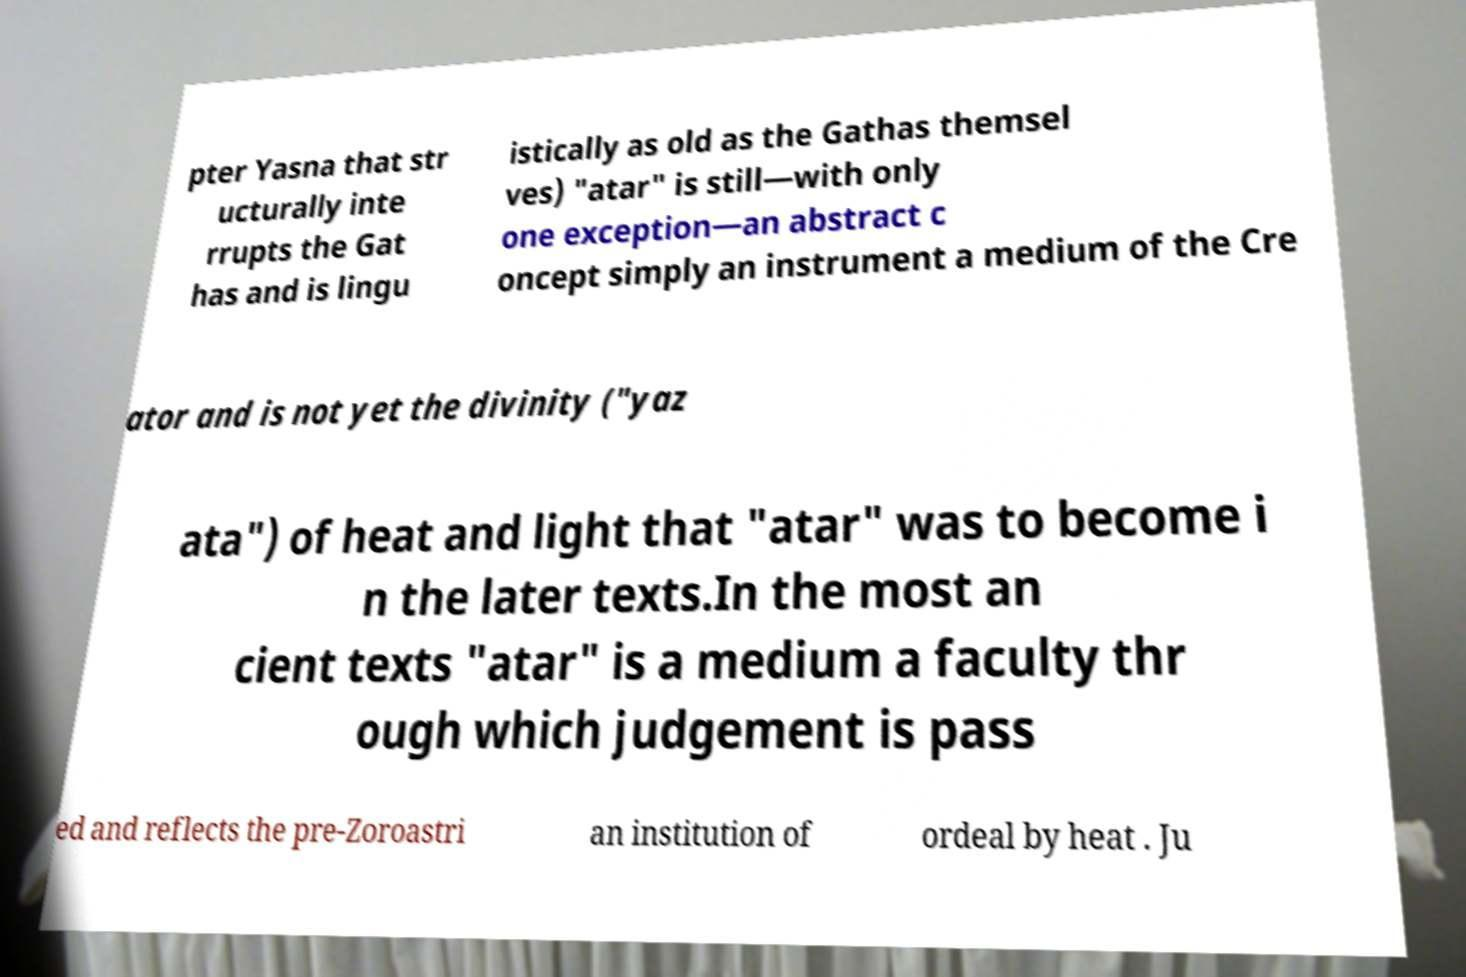Can you accurately transcribe the text from the provided image for me? pter Yasna that str ucturally inte rrupts the Gat has and is lingu istically as old as the Gathas themsel ves) "atar" is still—with only one exception—an abstract c oncept simply an instrument a medium of the Cre ator and is not yet the divinity ("yaz ata") of heat and light that "atar" was to become i n the later texts.In the most an cient texts "atar" is a medium a faculty thr ough which judgement is pass ed and reflects the pre-Zoroastri an institution of ordeal by heat . Ju 